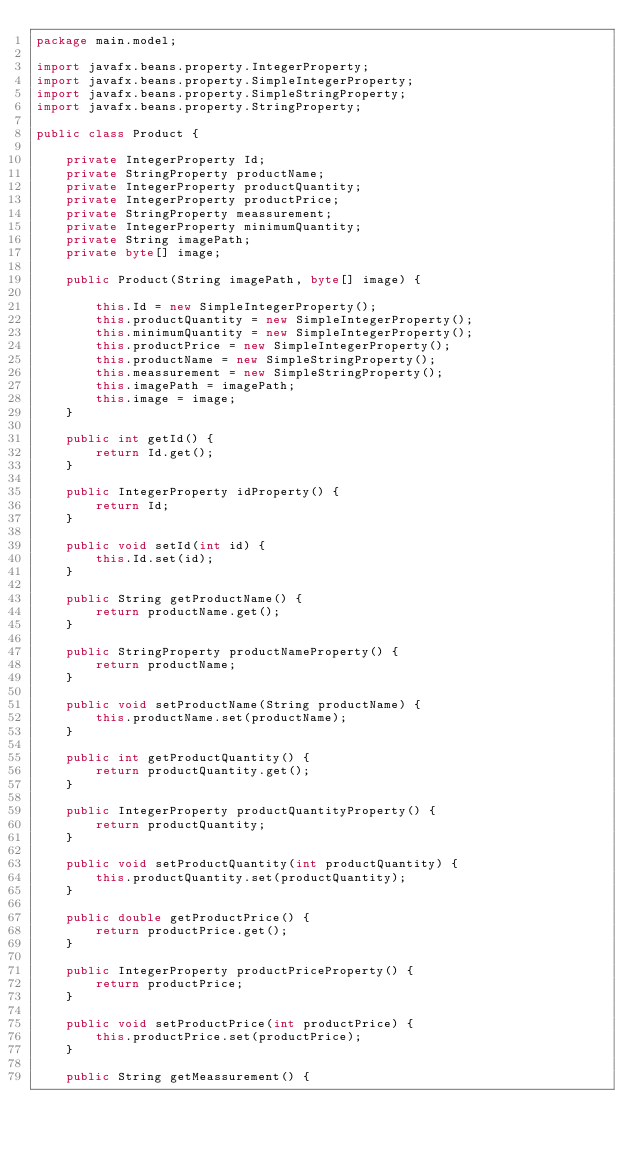Convert code to text. <code><loc_0><loc_0><loc_500><loc_500><_Java_>package main.model;

import javafx.beans.property.IntegerProperty;
import javafx.beans.property.SimpleIntegerProperty;
import javafx.beans.property.SimpleStringProperty;
import javafx.beans.property.StringProperty;

public class Product {

    private IntegerProperty Id;
    private StringProperty productName;
    private IntegerProperty productQuantity;
    private IntegerProperty productPrice;
    private StringProperty meassurement;
    private IntegerProperty minimumQuantity;
    private String imagePath;
    private byte[] image;

    public Product(String imagePath, byte[] image) {

        this.Id = new SimpleIntegerProperty();
        this.productQuantity = new SimpleIntegerProperty();
        this.minimumQuantity = new SimpleIntegerProperty();
        this.productPrice = new SimpleIntegerProperty();
        this.productName = new SimpleStringProperty();
        this.meassurement = new SimpleStringProperty();
        this.imagePath = imagePath;
        this.image = image;
    }

    public int getId() {
        return Id.get();
    }

    public IntegerProperty idProperty() {
        return Id;
    }

    public void setId(int id) {
        this.Id.set(id);
    }

    public String getProductName() {
        return productName.get();
    }

    public StringProperty productNameProperty() {
        return productName;
    }

    public void setProductName(String productName) {
        this.productName.set(productName);
    }

    public int getProductQuantity() {
        return productQuantity.get();
    }

    public IntegerProperty productQuantityProperty() {
        return productQuantity;
    }

    public void setProductQuantity(int productQuantity) {
        this.productQuantity.set(productQuantity);
    }

    public double getProductPrice() {
        return productPrice.get();
    }

    public IntegerProperty productPriceProperty() {
        return productPrice;
    }

    public void setProductPrice(int productPrice) {
        this.productPrice.set(productPrice);
    }

    public String getMeassurement() {</code> 